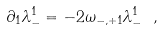Convert formula to latex. <formula><loc_0><loc_0><loc_500><loc_500>\partial _ { 1 } \lambda ^ { 1 } _ { - } = - 2 \omega _ { - , + 1 } \lambda ^ { 1 } _ { - } \ ,</formula> 